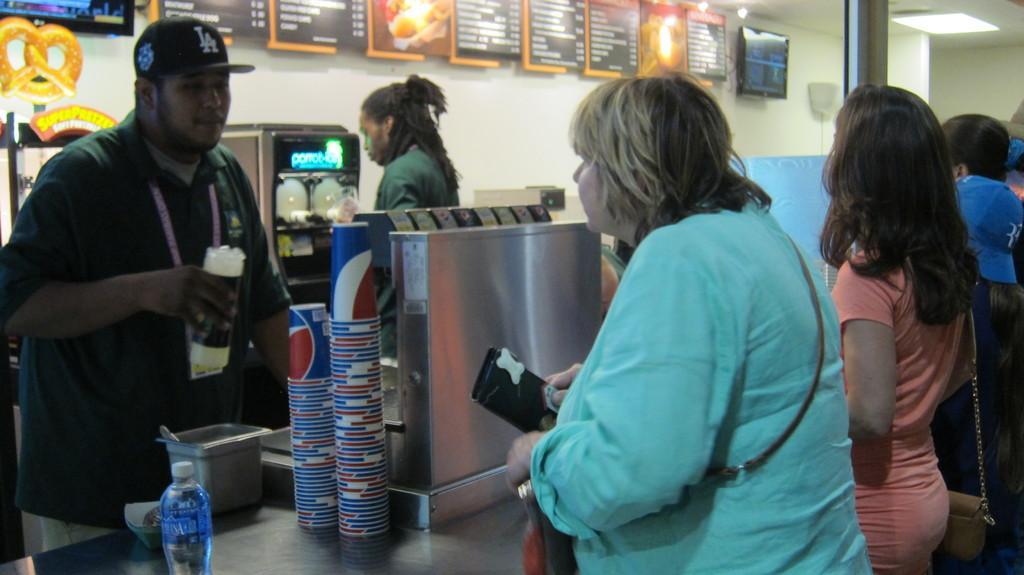How would you summarize this image in a sentence or two? In this image there are people standing in front of the table. On top of the table there is a water bottle. There are cups and a few other objects. On the left side of the image there are two machines on the table. In front of the table there is a person. In the background of the image there are photo frames and two televisions on the wall. On top of the image there are lights. On the right side of the image there is a pole. 